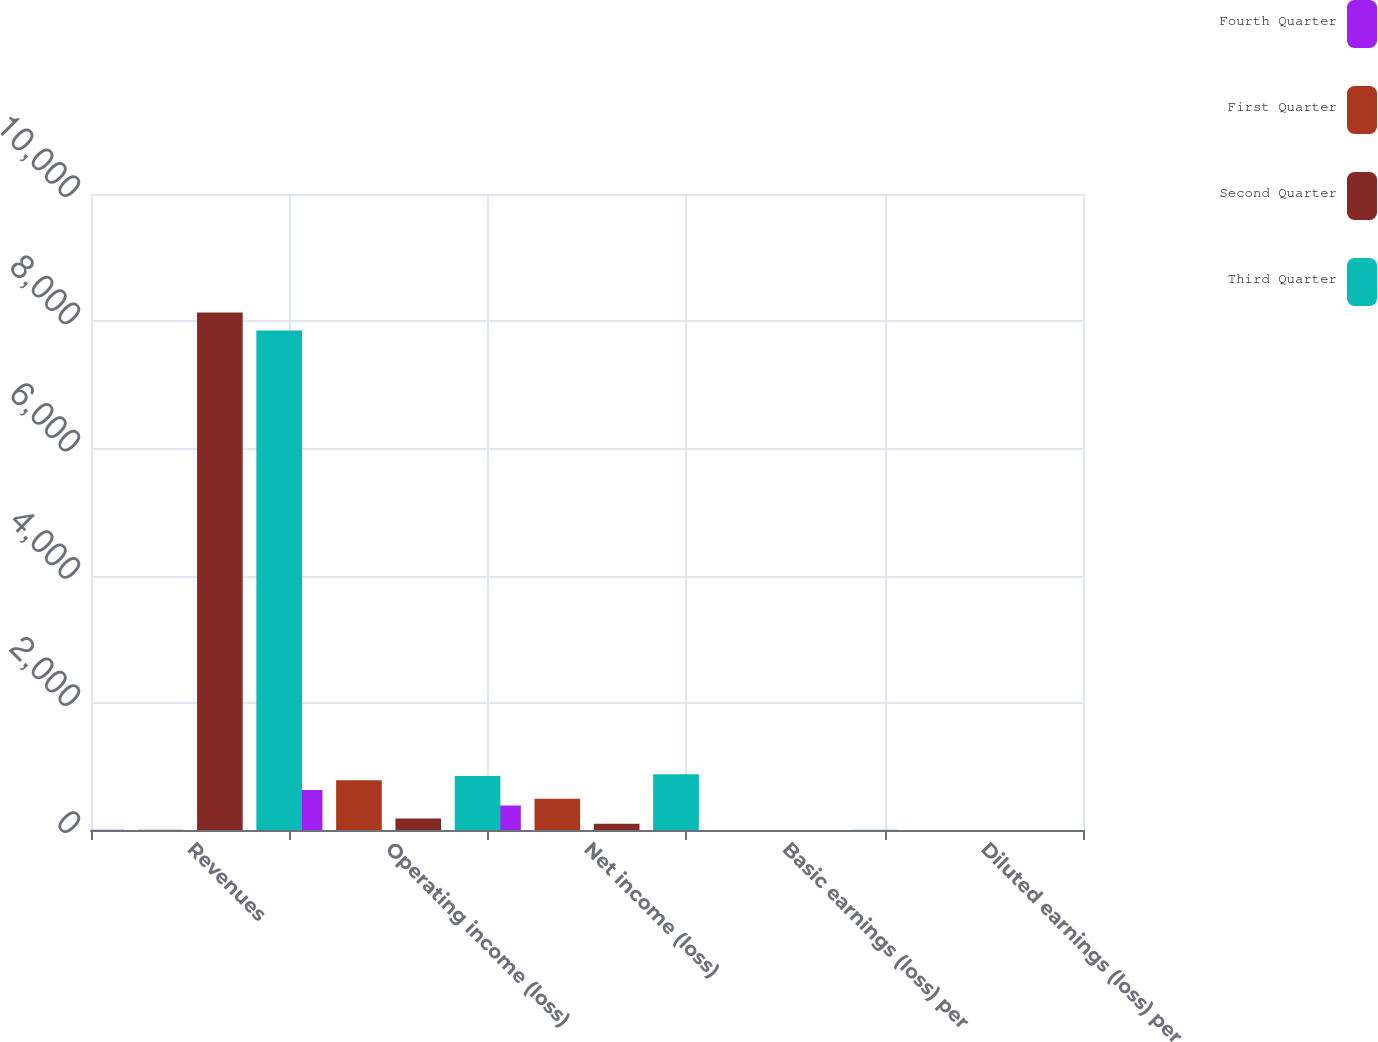<chart> <loc_0><loc_0><loc_500><loc_500><stacked_bar_chart><ecel><fcel>Revenues<fcel>Operating income (loss)<fcel>Net income (loss)<fcel>Basic earnings (loss) per<fcel>Diluted earnings (loss) per<nl><fcel>Fourth Quarter<fcel>2.82<fcel>630<fcel>384<fcel>1.23<fcel>1.58<nl><fcel>First Quarter<fcel>2.82<fcel>784<fcel>493<fcel>1.59<fcel>1.54<nl><fcel>Second Quarter<fcel>8137<fcel>182<fcel>97<fcel>0.31<fcel>1.26<nl><fcel>Third Quarter<fcel>7852<fcel>849<fcel>876<fcel>2.82<fcel>0.78<nl></chart> 